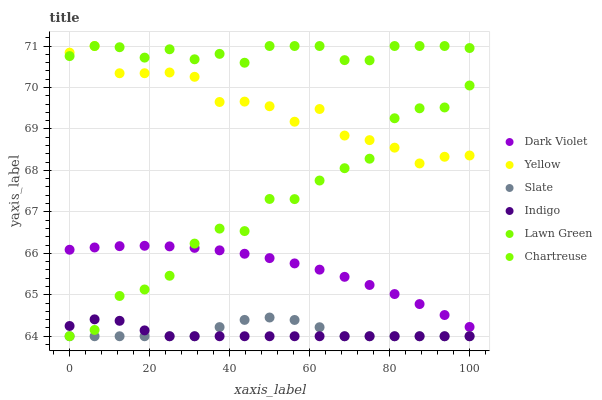Does Indigo have the minimum area under the curve?
Answer yes or no. Yes. Does Lawn Green have the maximum area under the curve?
Answer yes or no. Yes. Does Slate have the minimum area under the curve?
Answer yes or no. No. Does Slate have the maximum area under the curve?
Answer yes or no. No. Is Dark Violet the smoothest?
Answer yes or no. Yes. Is Chartreuse the roughest?
Answer yes or no. Yes. Is Indigo the smoothest?
Answer yes or no. No. Is Indigo the roughest?
Answer yes or no. No. Does Indigo have the lowest value?
Answer yes or no. Yes. Does Yellow have the lowest value?
Answer yes or no. No. Does Yellow have the highest value?
Answer yes or no. Yes. Does Slate have the highest value?
Answer yes or no. No. Is Dark Violet less than Lawn Green?
Answer yes or no. Yes. Is Dark Violet greater than Slate?
Answer yes or no. Yes. Does Yellow intersect Chartreuse?
Answer yes or no. Yes. Is Yellow less than Chartreuse?
Answer yes or no. No. Is Yellow greater than Chartreuse?
Answer yes or no. No. Does Dark Violet intersect Lawn Green?
Answer yes or no. No. 